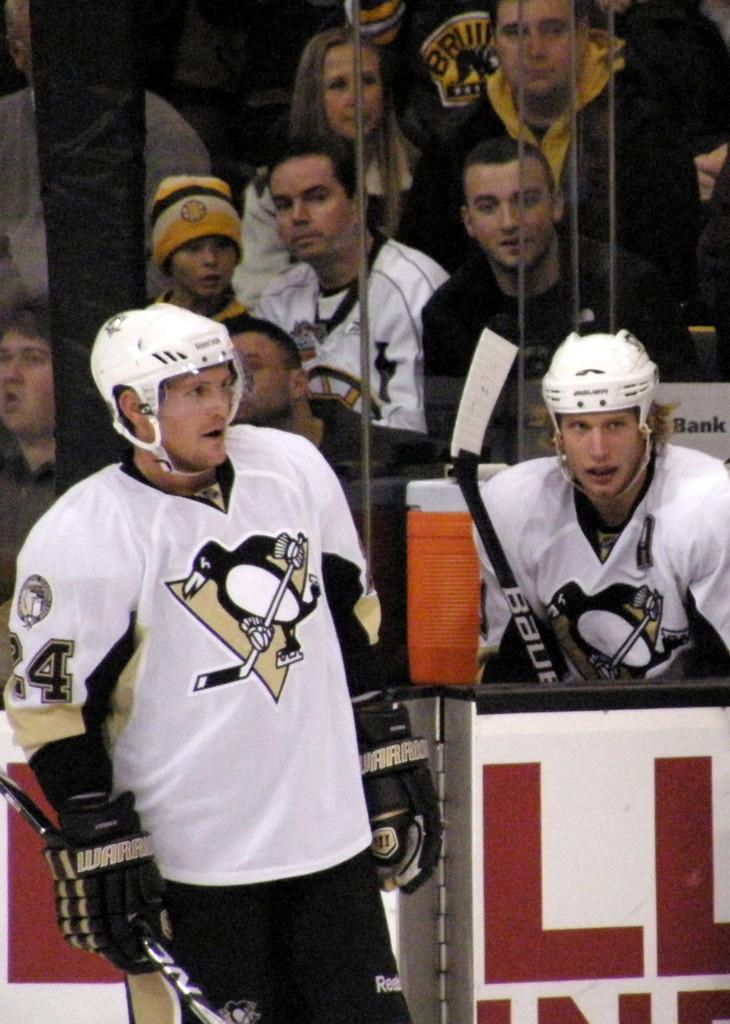Could you give a brief overview of what you see in this image? In this image we can see some people and other objects. At the bottom of the image there is a name board, person and an object. 